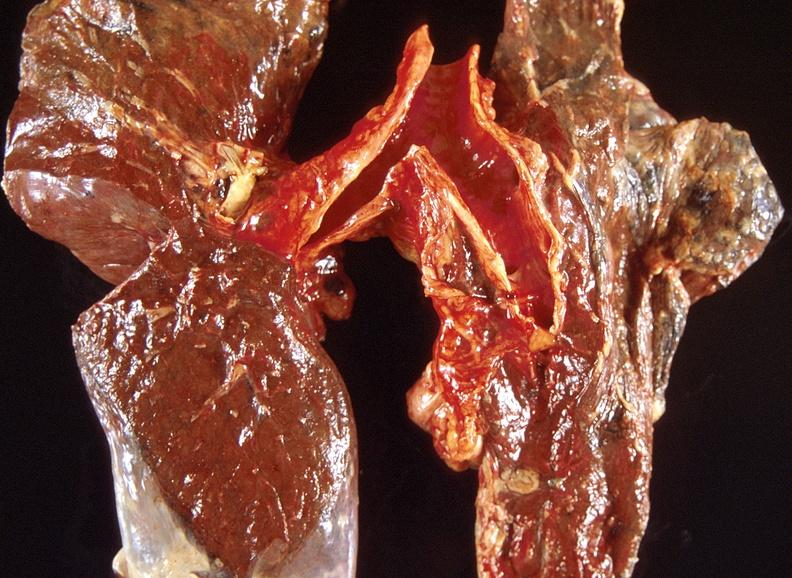s respiratory present?
Answer the question using a single word or phrase. Yes 